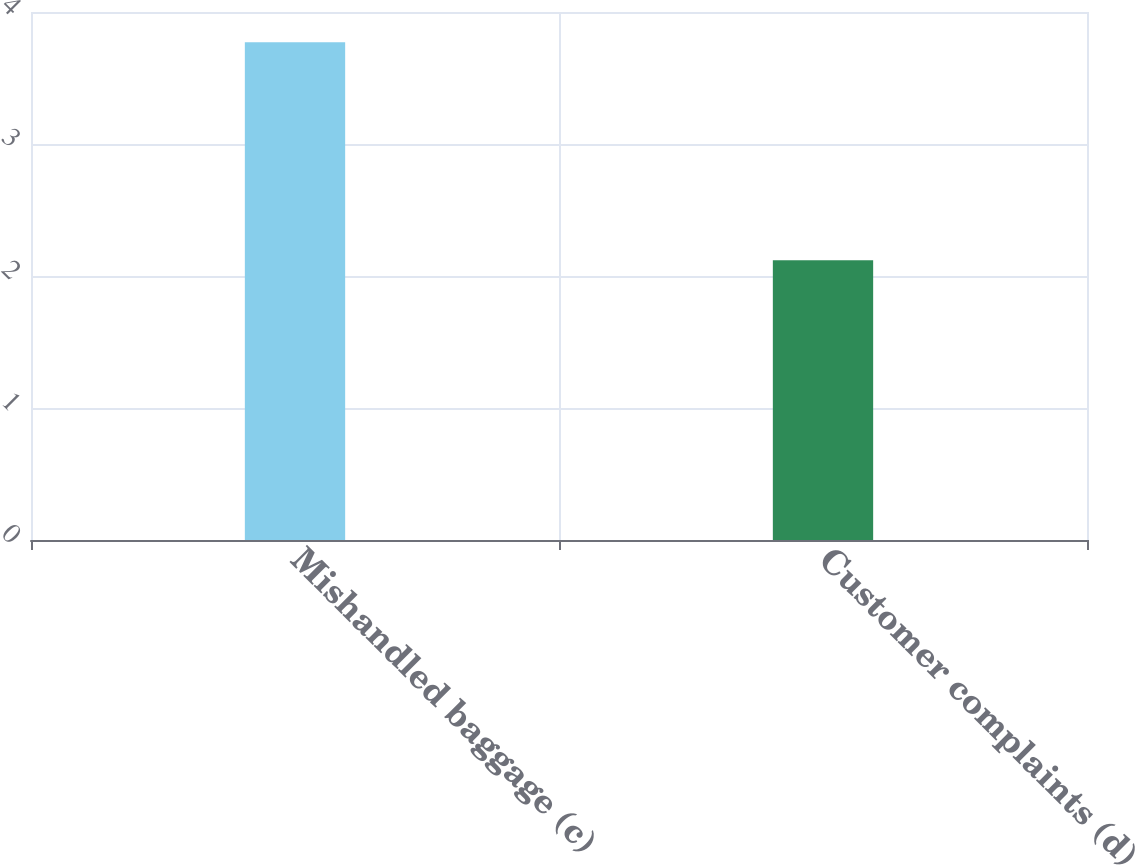<chart> <loc_0><loc_0><loc_500><loc_500><bar_chart><fcel>Mishandled baggage (c)<fcel>Customer complaints (d)<nl><fcel>3.77<fcel>2.12<nl></chart> 